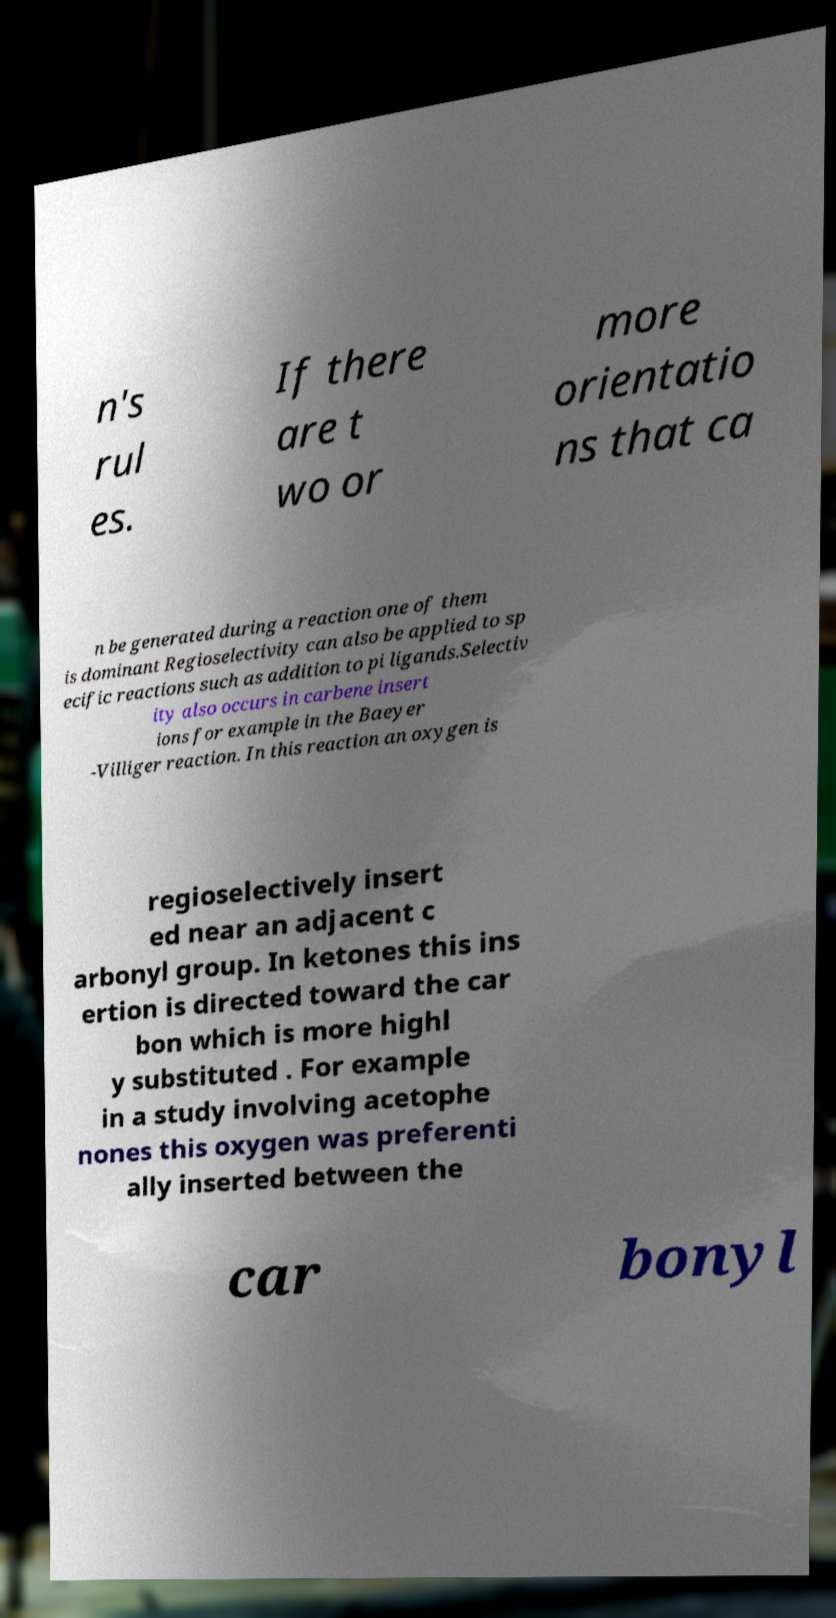What messages or text are displayed in this image? I need them in a readable, typed format. n's rul es. If there are t wo or more orientatio ns that ca n be generated during a reaction one of them is dominant Regioselectivity can also be applied to sp ecific reactions such as addition to pi ligands.Selectiv ity also occurs in carbene insert ions for example in the Baeyer -Villiger reaction. In this reaction an oxygen is regioselectively insert ed near an adjacent c arbonyl group. In ketones this ins ertion is directed toward the car bon which is more highl y substituted . For example in a study involving acetophe nones this oxygen was preferenti ally inserted between the car bonyl 